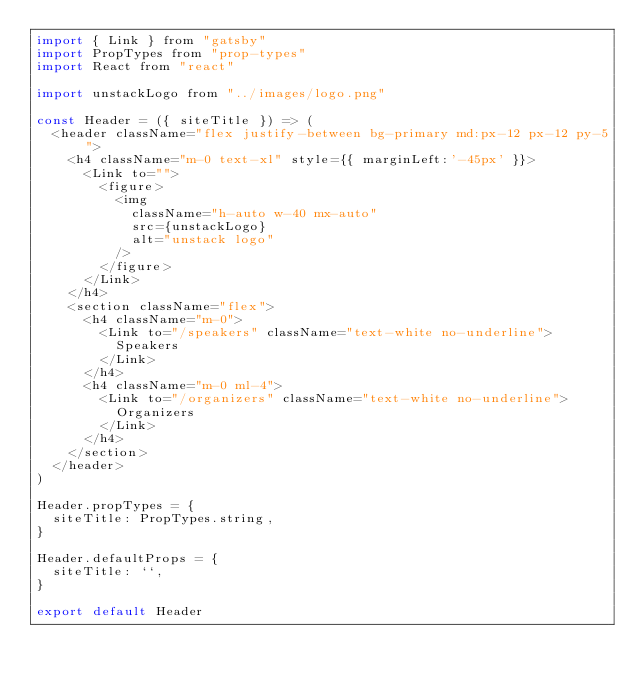Convert code to text. <code><loc_0><loc_0><loc_500><loc_500><_JavaScript_>import { Link } from "gatsby"
import PropTypes from "prop-types"
import React from "react"

import unstackLogo from "../images/logo.png"

const Header = ({ siteTitle }) => (
  <header className="flex justify-between bg-primary md:px-12 px-12 py-5">
    <h4 className="m-0 text-xl" style={{ marginLeft:'-45px' }}>
      <Link to="">
        <figure>
          <img
            className="h-auto w-40 mx-auto"
            src={unstackLogo}
            alt="unstack logo"
          />
        </figure>
      </Link>
    </h4>
    <section className="flex">
      <h4 className="m-0">
        <Link to="/speakers" className="text-white no-underline">
          Speakers
        </Link>
      </h4>
      <h4 className="m-0 ml-4">
        <Link to="/organizers" className="text-white no-underline">
          Organizers
        </Link>
      </h4>
    </section>
  </header>
)

Header.propTypes = {
  siteTitle: PropTypes.string,
}

Header.defaultProps = {
  siteTitle: ``,
}

export default Header
</code> 